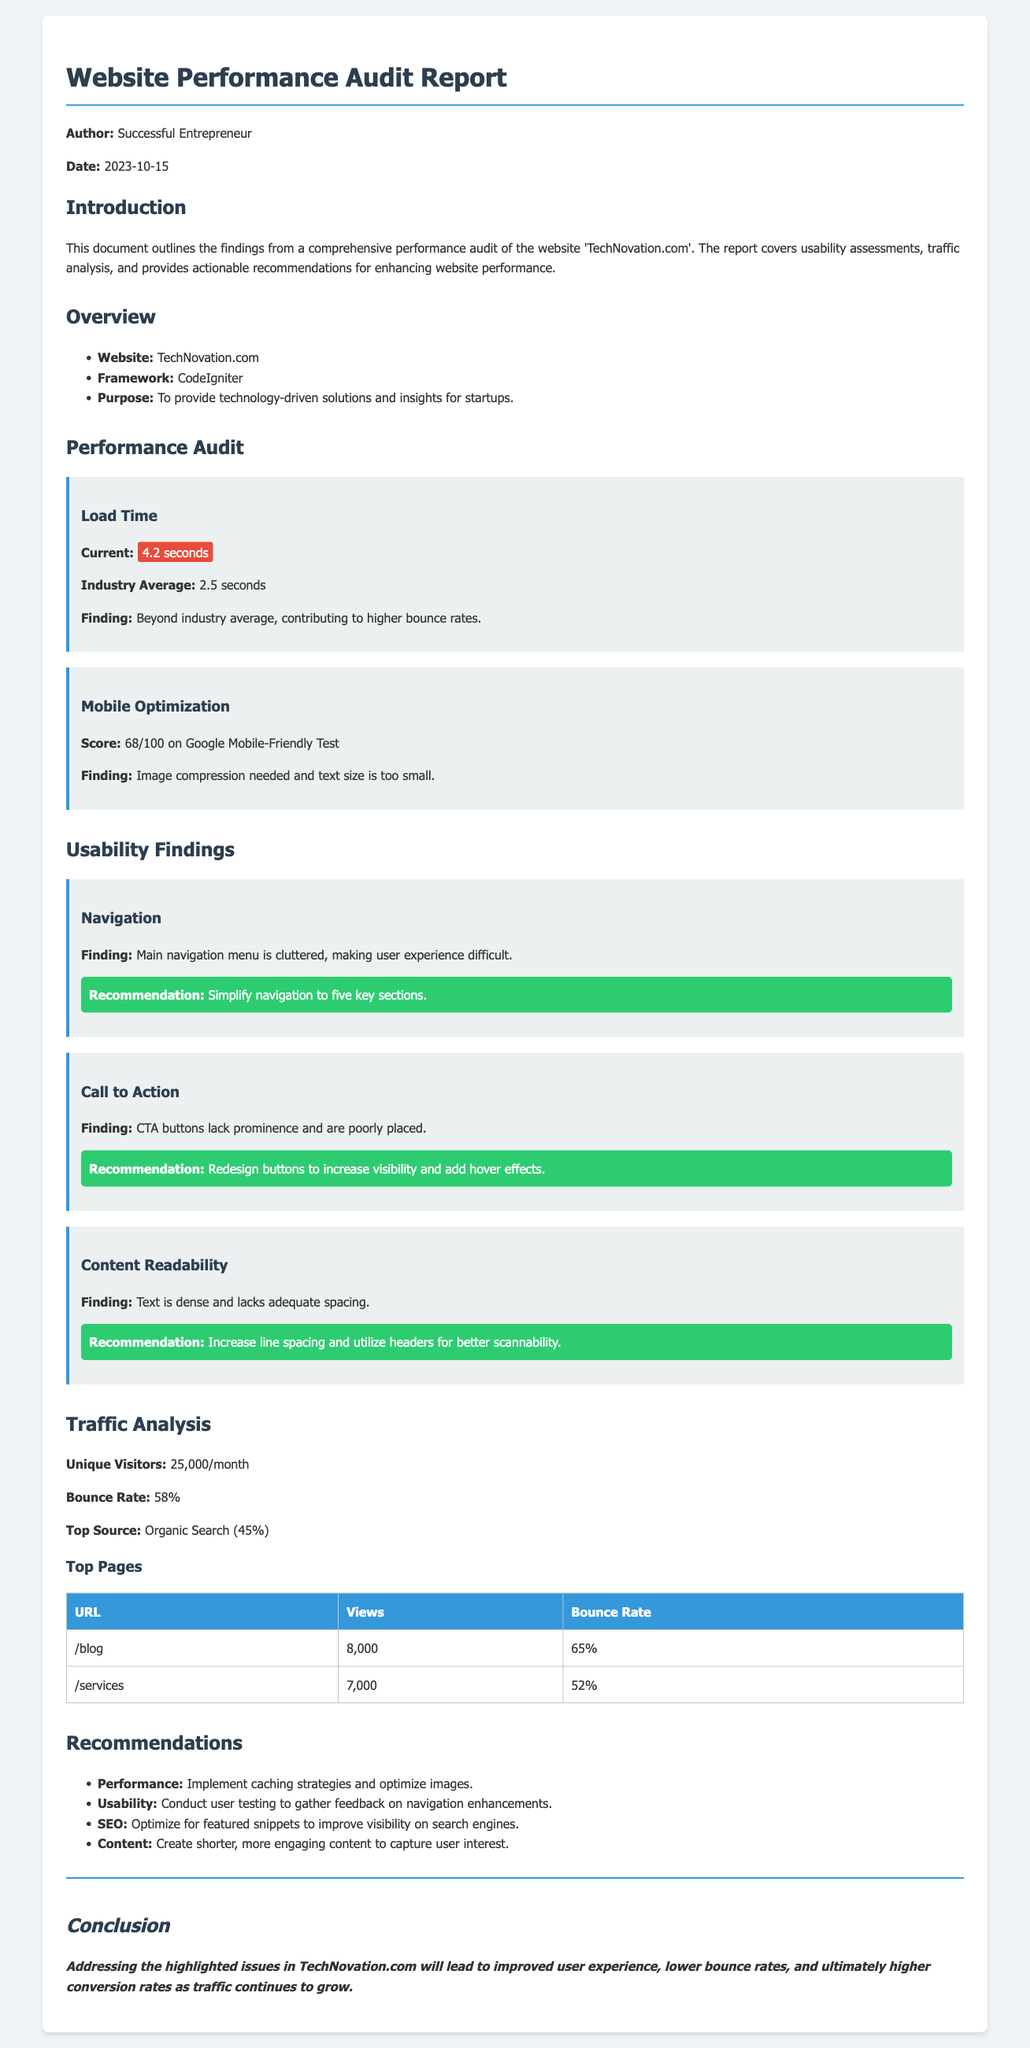What is the current load time of the website? The current load time of the website is mentioned as 4.2 seconds.
Answer: 4.2 seconds What is the mobile optimization score? The mobile optimization score provided in the document is 68 out of 100.
Answer: 68/100 What is the unique visitors count per month? The unique visitors count per month is specified as 25,000.
Answer: 25,000 What is the top source of traffic? The document states that the top source of traffic is organic search.
Answer: Organic Search Which section should be simplified according to the usability findings? The main navigation menu is identified as cluttered and needs simplification.
Answer: Main navigation menu What finding is related to Call to Action buttons? The finding states that the CTA buttons lack prominence and are poorly placed.
Answer: Lack prominence and poorly placed What is the average bounce rate according to the traffic analysis? The bounce rate according to the traffic analysis is given as 58%.
Answer: 58% Which two pages had the highest views? The highest views are for the pages /blog and /services.
Answer: /blog and /services What is one of the recommendations for performance improvement? One of the recommendations for performance improvement is to implement caching strategies.
Answer: Implement caching strategies 